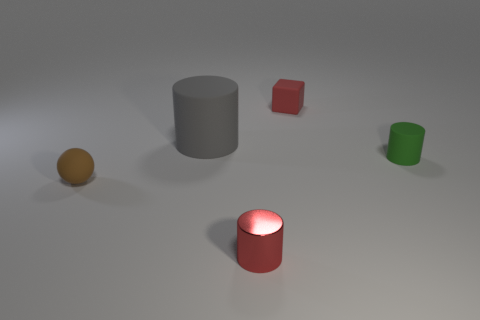Is there any other thing that is the same size as the gray cylinder?
Keep it short and to the point. No. Is the color of the tiny rubber sphere the same as the matte cylinder to the right of the gray thing?
Provide a short and direct response. No. Do the tiny matte cube and the small metal cylinder have the same color?
Offer a terse response. Yes. Is the number of red metal things less than the number of gray rubber cubes?
Make the answer very short. No. What number of other things are the same color as the big rubber cylinder?
Your response must be concise. 0. How many matte cylinders are there?
Provide a short and direct response. 2. Is the number of matte objects that are behind the brown rubber thing less than the number of large rubber cylinders?
Keep it short and to the point. No. Do the red object in front of the tiny brown rubber ball and the tiny brown thing have the same material?
Provide a succinct answer. No. There is a tiny red thing that is right of the red object that is in front of the rubber cylinder on the right side of the shiny object; what shape is it?
Give a very brief answer. Cube. Is there a red shiny sphere of the same size as the red cylinder?
Your response must be concise. No. 